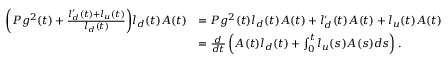<formula> <loc_0><loc_0><loc_500><loc_500>\begin{array} { r l } { \left ( P g ^ { 2 } ( t ) + \frac { l _ { d } ^ { \prime } ( t ) + l _ { u } ( t ) } { l _ { d } ( t ) } \right ) l _ { d } ( t ) A ( t ) } & { = P g ^ { 2 } ( t ) l _ { d } ( t ) A ( t ) + l _ { d } ^ { \prime } ( t ) A ( t ) + l _ { u } ( t ) A ( t ) } \\ & { = \frac { d } { d t } \left ( A ( t ) l _ { d } ( t ) + \int _ { 0 } ^ { t } l _ { u } ( s ) A ( s ) d s \right ) . } \end{array}</formula> 